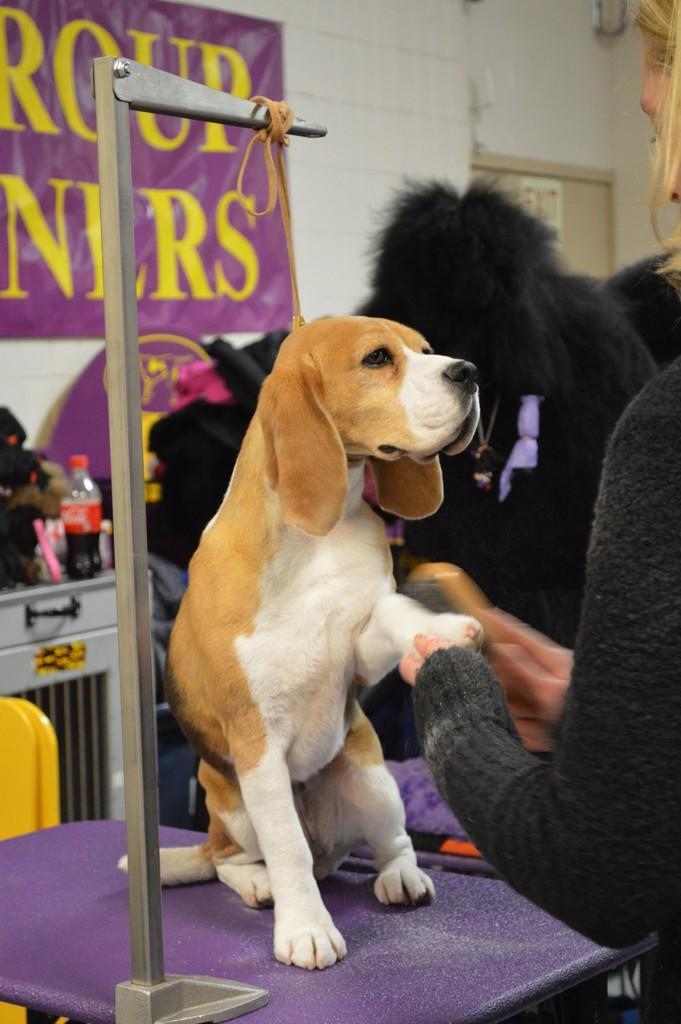Please provide a concise description of this image. In the center of the image we can see a dog on the table. On the right there is a person cleaning the dog. In the background there is a wall we can see a banner. On the left there is a table and there is a bottle placed on the table. 